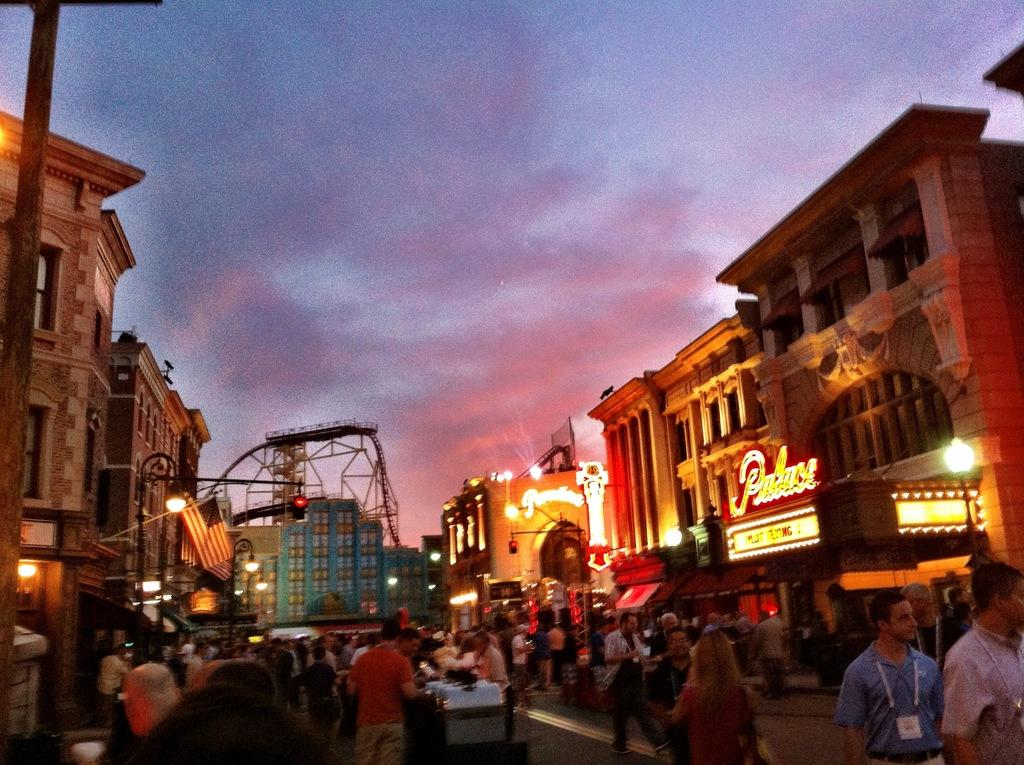What type of structures can be seen in the image? There are buildings in the image. Are there any living beings present in the image? Yes, there are people in the image. What additional objects can be seen in the image besides buildings and people? There are banners in the image. What is visible in the background of the image? The sky is visible in the image, and clouds are present in the sky. What type of skin is being used to make the banners in the image? There is no information about the material used for the banners in the image, and no mention of skin being used for any purpose. 